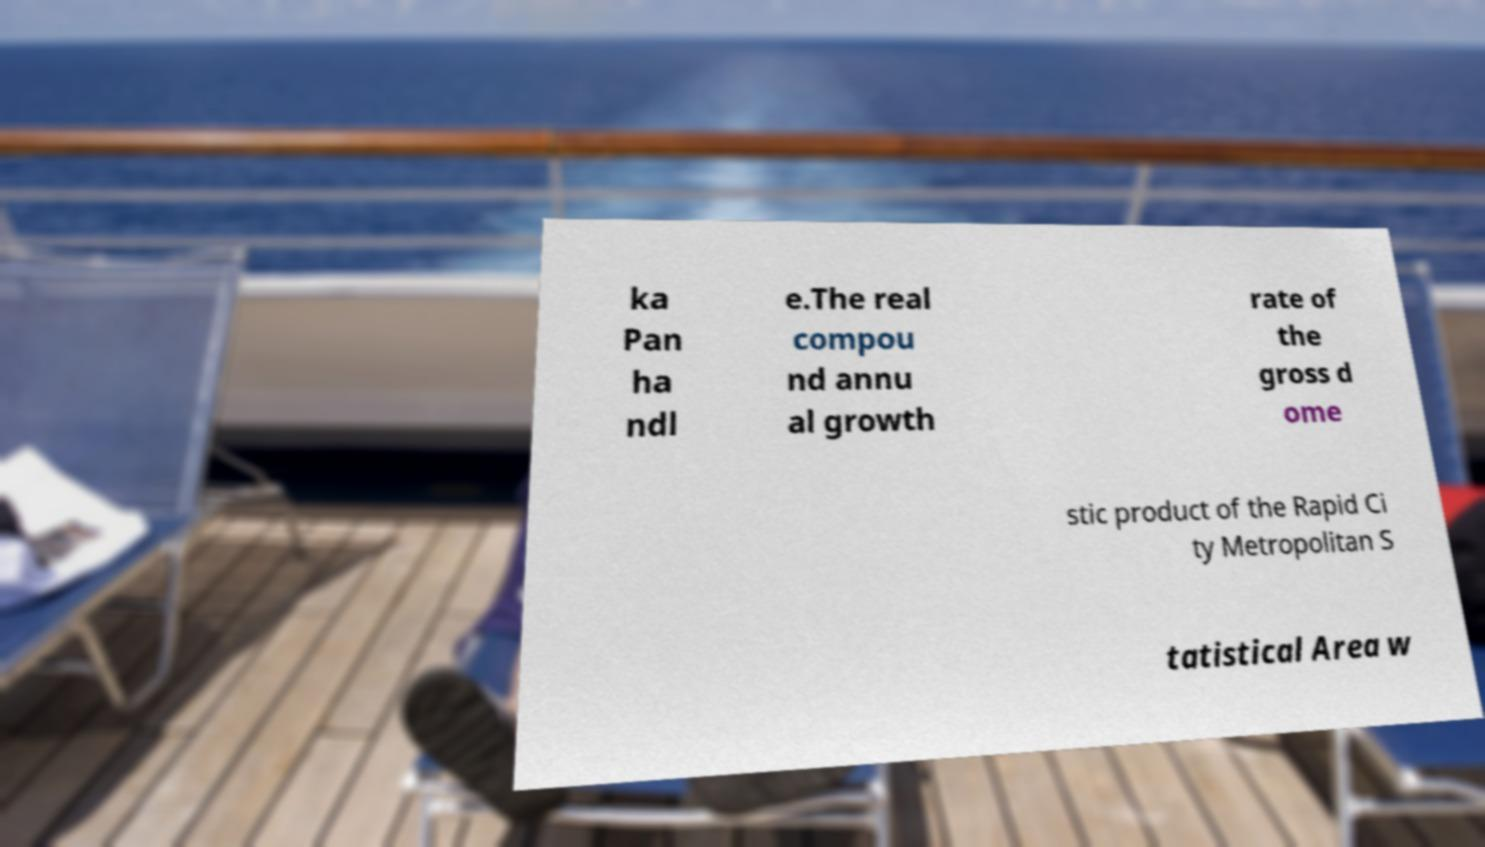Please read and relay the text visible in this image. What does it say? ka Pan ha ndl e.The real compou nd annu al growth rate of the gross d ome stic product of the Rapid Ci ty Metropolitan S tatistical Area w 